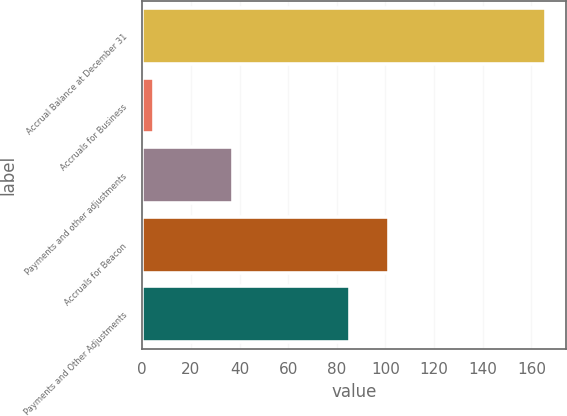Convert chart to OTSL. <chart><loc_0><loc_0><loc_500><loc_500><bar_chart><fcel>Accrual Balance at December 31<fcel>Accruals for Business<fcel>Payments and other adjustments<fcel>Accruals for Beacon<fcel>Payments and Other Adjustments<nl><fcel>166<fcel>5<fcel>37.2<fcel>101.6<fcel>85.5<nl></chart> 